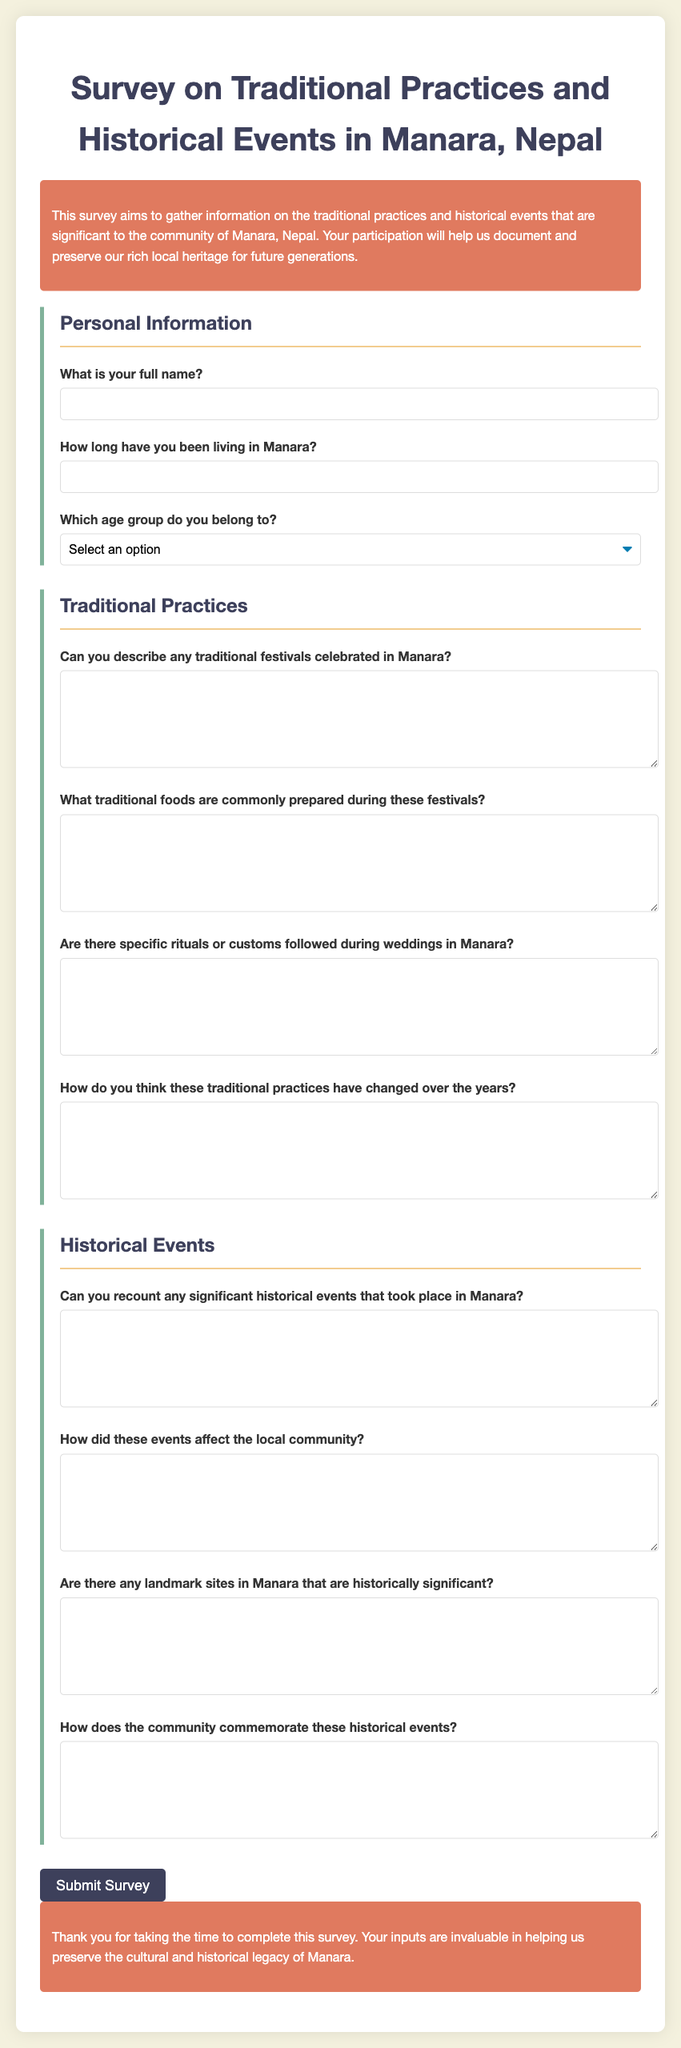What is the title of the document? The title of the document is the main heading at the top, indicating the subject of the survey.
Answer: Survey on Traditional Practices and Historical Events in Manara, Nepal What is the purpose of the survey? The purpose can be found in the introductory paragraph, describing the survey's aim.
Answer: To gather information on traditional practices and historical events How many age groups are listed in the document? The number of age groups can be counted from the options provided in the personal information section.
Answer: Five What is the first question in the Traditional Practices section? The first question can be identified by reading the questions under that section.
Answer: Can you describe any traditional festivals celebrated in Manara? How should participants submit the survey? Participants will submit the survey based on the button provided at the end of the form.
Answer: Click the Submit Survey button What type of information does the Historical Events section ask for? The types of inquiries can be categorized by examining the content of the questions in that section.
Answer: Significant historical events and their impacts 